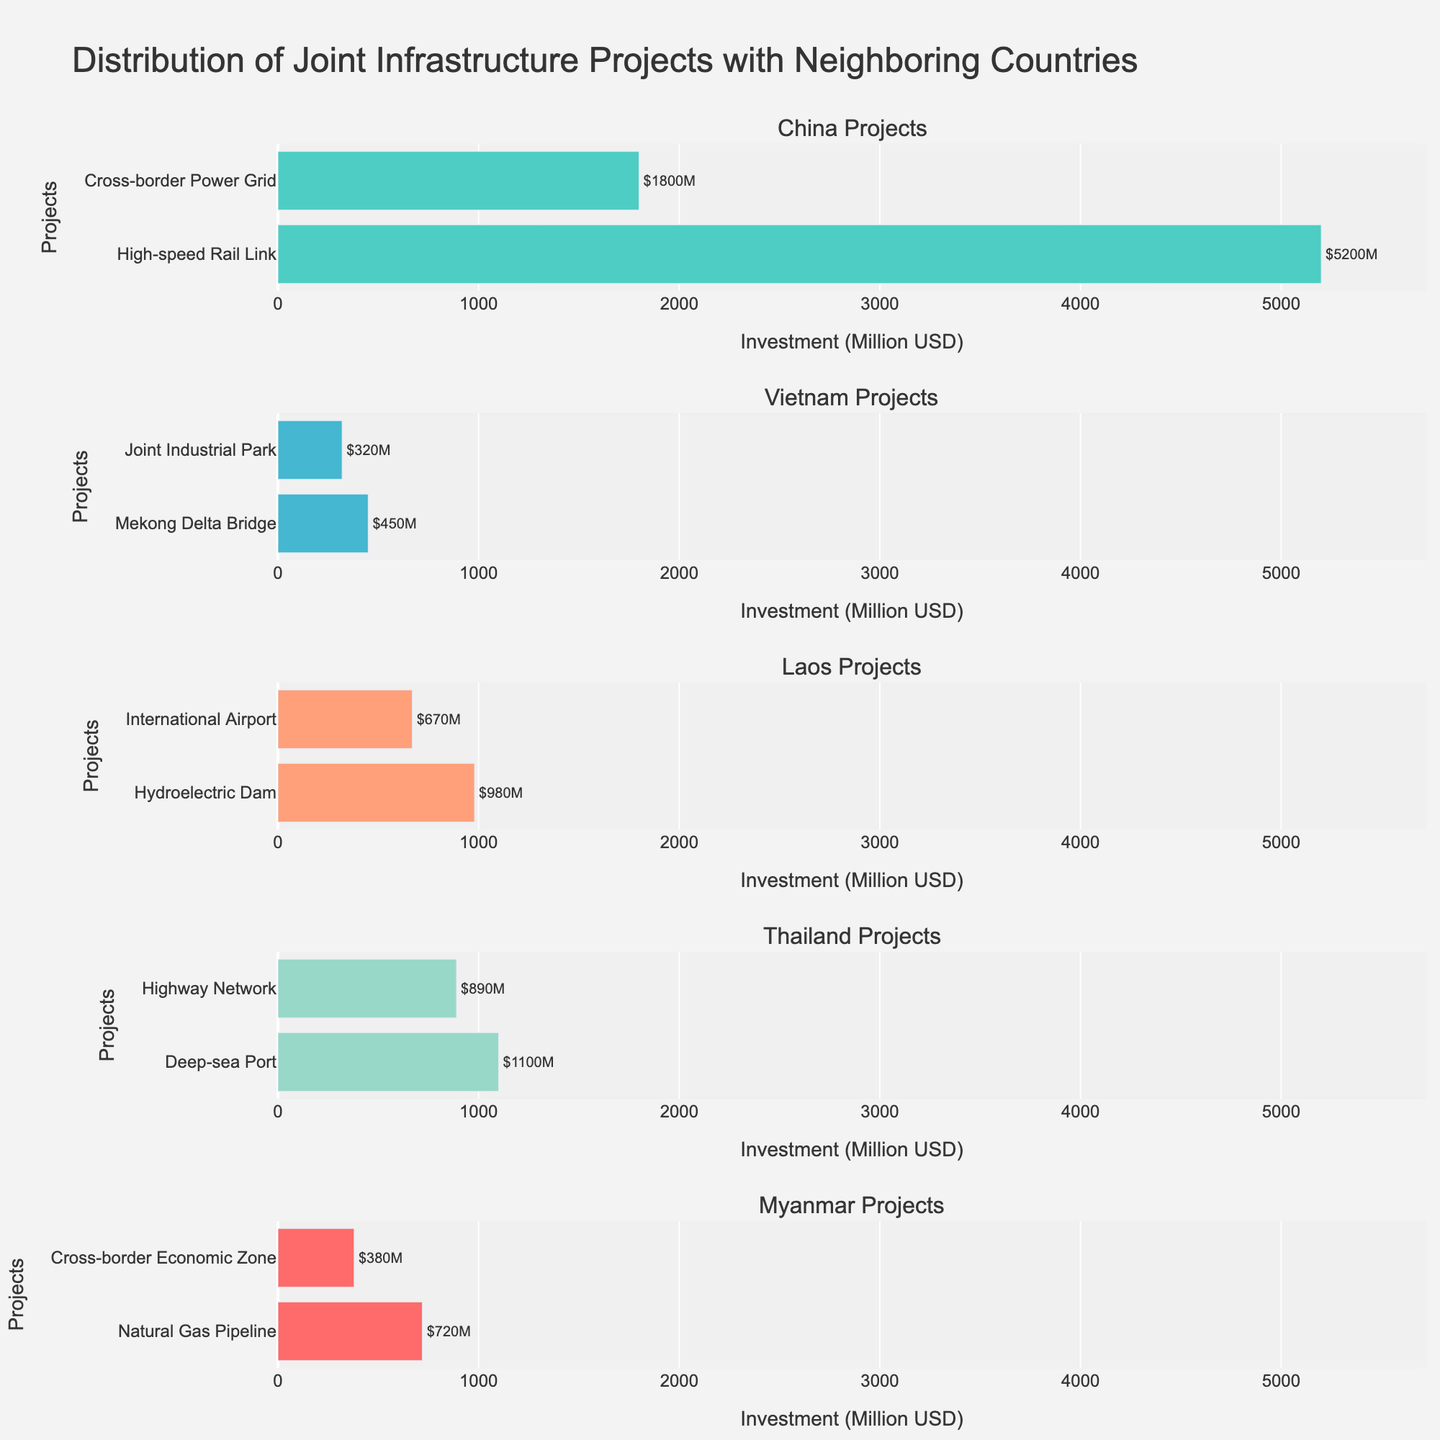How many goals did Birgit Prinz score? The plot "Goals" shows the number of goals scored by each player. Birgit Prinz has a bar indicating she scored 10 goals.
Answer: 10 How many tournaments did Pernille Harder participate in? The plot "Tournaments" shows the number of tournaments. Pernille Harder has participated in 4 tournaments (from 2009 to 2022 as stated in the dataset).
Answer: 4 Which player has the highest goals per tournament? The plot "Goals per Tournament" shows the normalized scoring rates. Birgit Prinz has the highest, indicated by the tallest bar on this subplot.
Answer: Birgit Prinz Do any players have bars of the same height in the Goals chart? If yes, who are they? On the "Goals" chart, identify bars of equal height. Three players, Vivianne Miedema, Pernille Harder, and Lotta Schelin, each have bars reaching the 5-goal mark.
Answer: Vivianne Miedema, Pernille Harder, Lotta Schelin How does Beth Mead’s goals per tournament compare to Vivianne Miedema’s? Compare the heights of the bars for Beth Mead and Vivianne Miedema in the "Goals per Tournament" plot. Beth Mead's bar is taller, indicating a higher average number of goals per tournament.
Answer: Beth Mead has a higher average Which country's player has participated in the earliest UEFA Women's Euro tournament based on the timeline chart? Observe the "Timeline" chart, looking for the earliest year marker. Carolina Morace from Italy participated in 1984, the earliest on the chart.
Answer: Italy Which player's participation spans the most years but is not the highest scorer? On the "Tournaments" chart combined with the "Timeline," identify players with longer spans not having the top goal count. Caroline Graham Hansen's span from 2013-2022 shows she spans 9 years but is not the top scorer.
Answer: Caroline Graham Hansen What is the total number of goals scored by players from Germany? Sum the goals of German players from the "Goals" plot. Birgit Prinz (10) and Inka Grings (9) sum up to 19 goals.
Answer: 19 